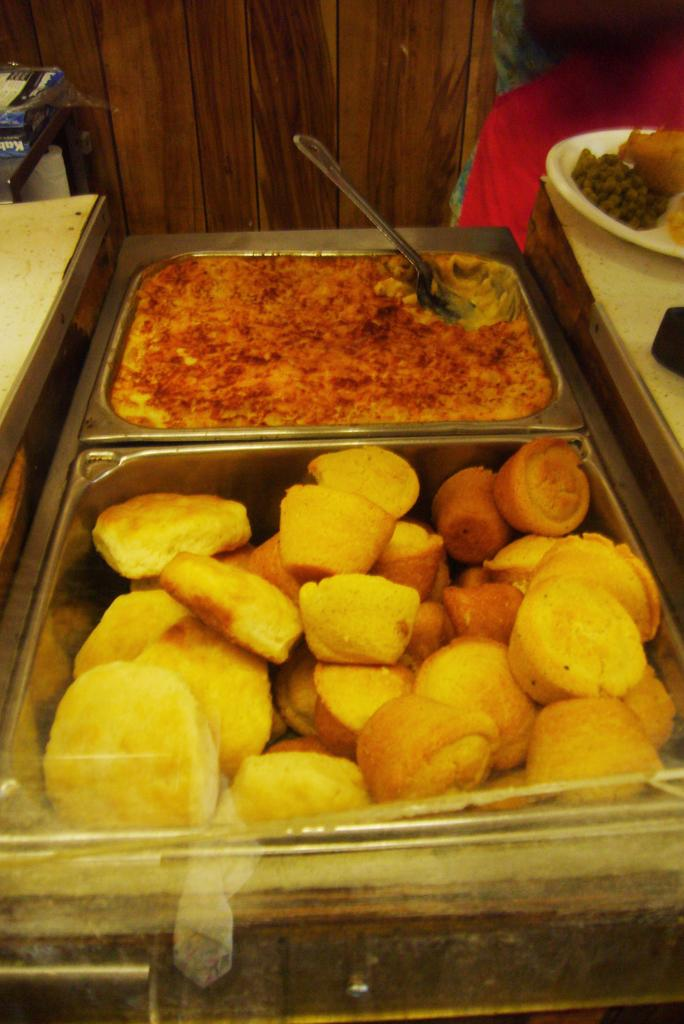What is present in the trays in the image? There are food items in the trays. What is another location where food items can be seen in the image? Food items can also be seen on a plate. What type of furniture is visible in the image? There are tables in the image. What can be seen in the background of the image? There are objects visible in the background. What direction is the Earth facing in the image? The image does not depict the Earth, so it is not possible to determine the direction it is facing. 